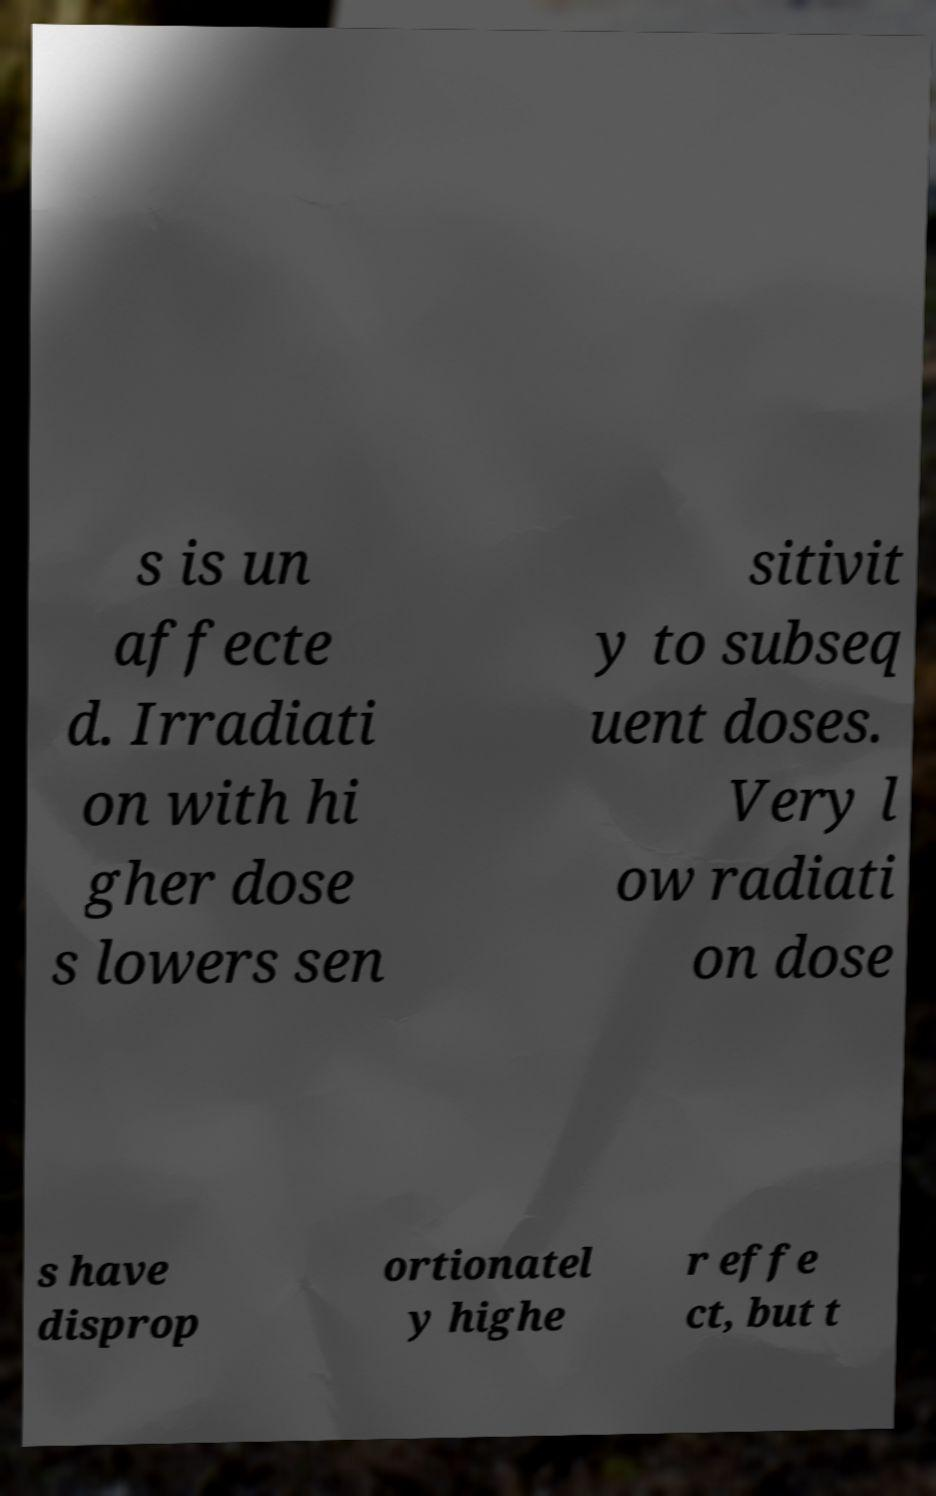I need the written content from this picture converted into text. Can you do that? s is un affecte d. Irradiati on with hi gher dose s lowers sen sitivit y to subseq uent doses. Very l ow radiati on dose s have disprop ortionatel y highe r effe ct, but t 